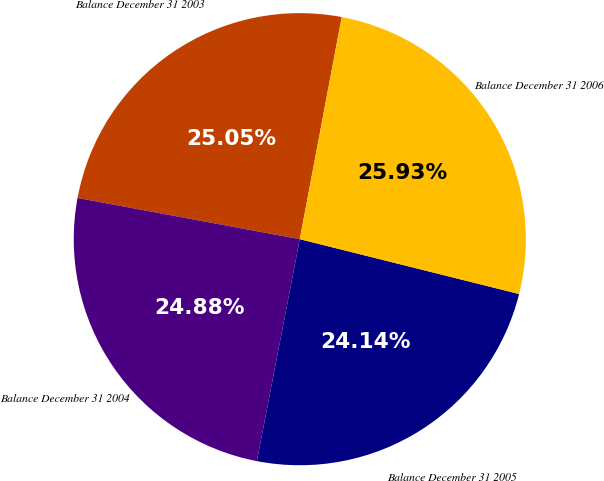Convert chart. <chart><loc_0><loc_0><loc_500><loc_500><pie_chart><fcel>Balance December 31 2003<fcel>Balance December 31 2004<fcel>Balance December 31 2005<fcel>Balance December 31 2006<nl><fcel>25.05%<fcel>24.88%<fcel>24.14%<fcel>25.93%<nl></chart> 